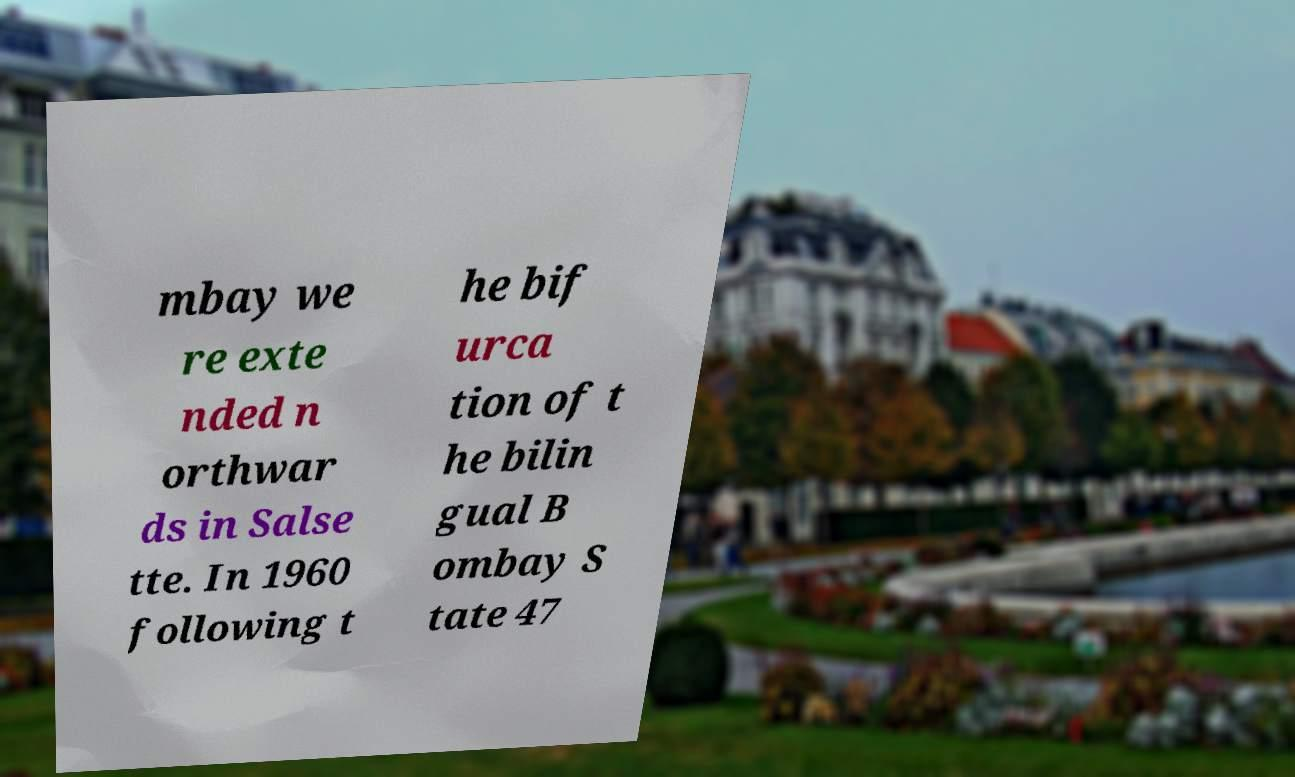Please read and relay the text visible in this image. What does it say? mbay we re exte nded n orthwar ds in Salse tte. In 1960 following t he bif urca tion of t he bilin gual B ombay S tate 47 